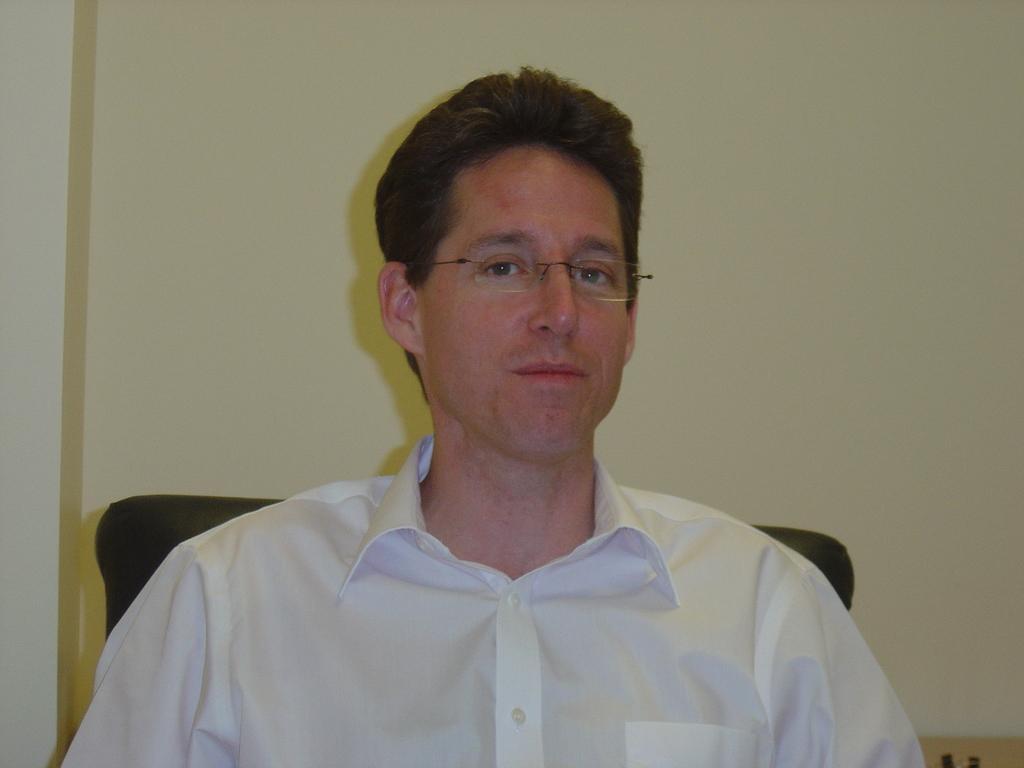In one or two sentences, can you explain what this image depicts? In this picture I can see a man sitting in the chair and I can see a wall in the background. 